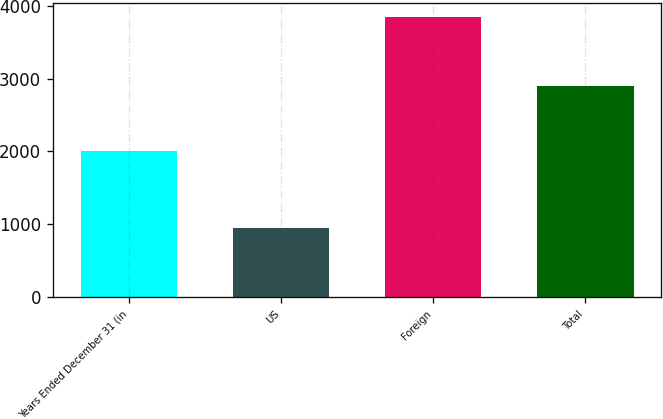<chart> <loc_0><loc_0><loc_500><loc_500><bar_chart><fcel>Years Ended December 31 (in<fcel>US<fcel>Foreign<fcel>Total<nl><fcel>2012<fcel>948<fcel>3839<fcel>2891<nl></chart> 